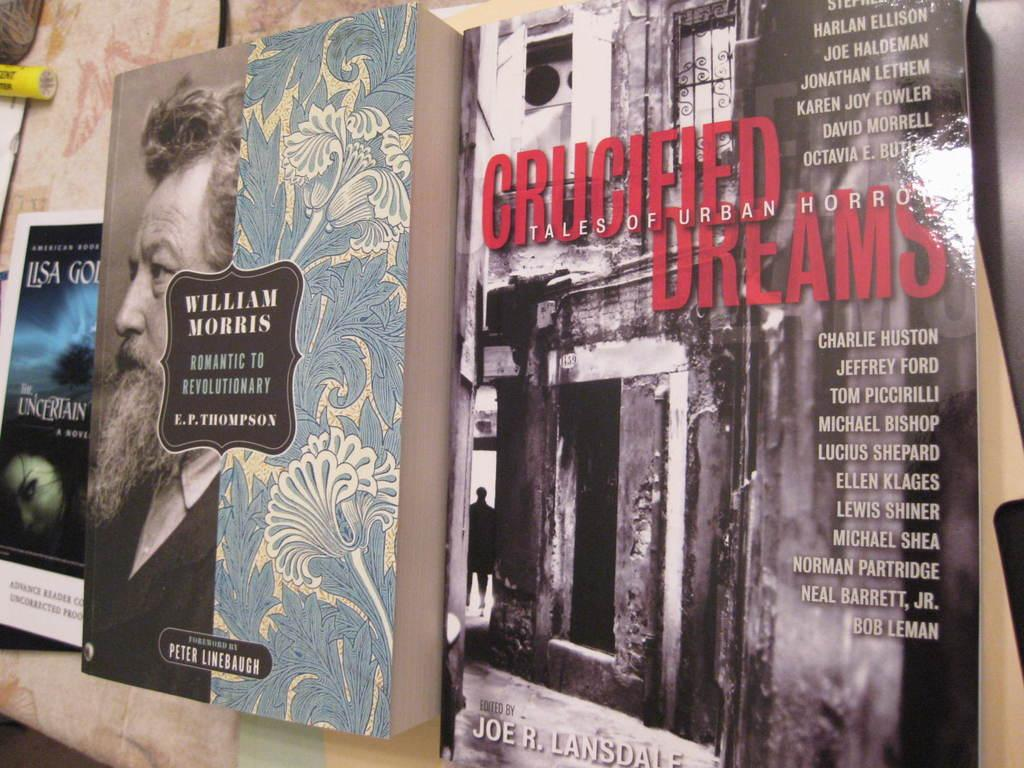<image>
Offer a succinct explanation of the picture presented. A book by William Morris sits on display on a shelf among other books 